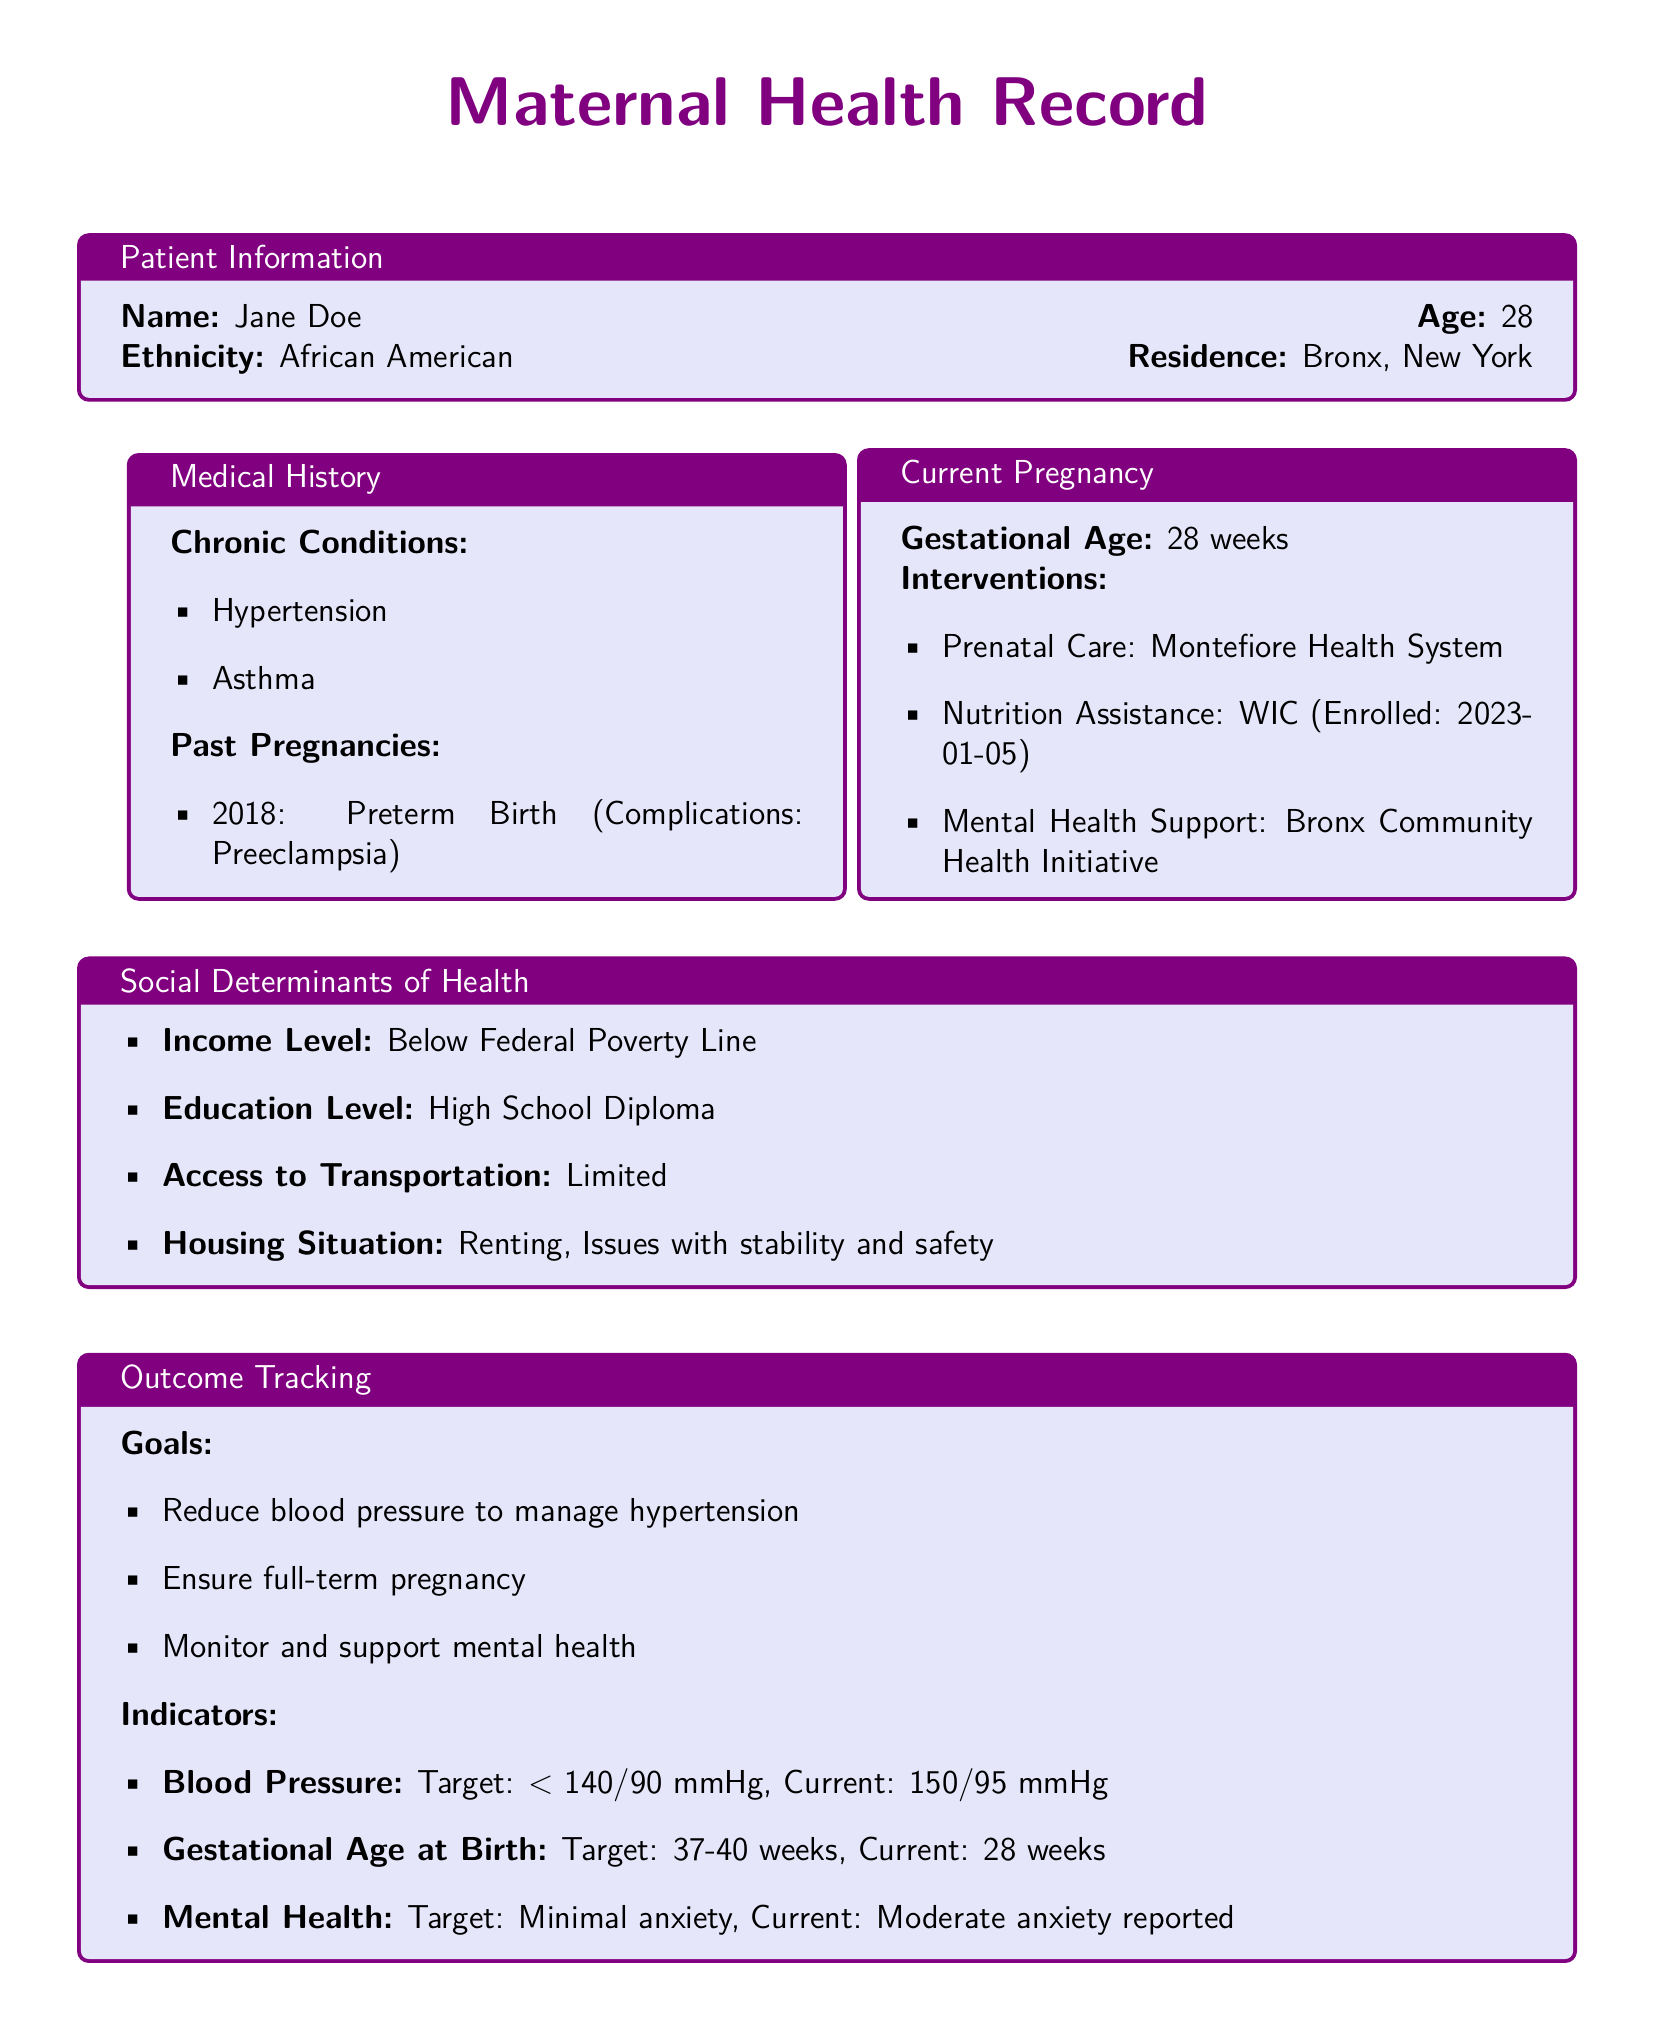What is the patient's name? The patient's name is explicitly stated in the Patient Information section of the document.
Answer: Jane Doe What is the patient's age? The patient's age is provided alongside her name in the Patient Information section.
Answer: 28 What chronic condition does the patient have? The document lists chronic conditions under the Medical History section.
Answer: Hypertension What is the current gestational age? The gestational age is clearly mentioned in the Current Pregnancy section.
Answer: 28 weeks What is the target blood pressure for the patient? The target blood pressure is specified in the Outcome Tracking section.
Answer: < 140/90 mmHg What interventions is the patient enrolled in for nutrition assistance? The specific intervention for nutrition assistance is listed in the Current Pregnancy section.
Answer: WIC What is the income level of the patient? The income level is indicated in the Social Determinants of Health section.
Answer: Below Federal Poverty Line What is the current mental health status reported by the patient? The current mental health status is detailed in the Outcome Tracking section.
Answer: Moderate anxiety reported What past pregnancy complication did the patient experience? The complication is mentioned in the Past Pregnancies subsection of the Medical History.
Answer: Preeclampsia 